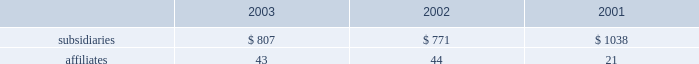Dividends from subsidiaries and affiliates cash dividends received from consolidated subsidiaries and from affiliates accounted for by the equity method were as follows ( in millions ) : .
Guarantees and letters of credit guarantees 2014in connection with certain of its project financing , acquisition , and power purchase agreements , the company has expressly undertaken limited obligations and commitments , most of which will only be effective or will be terminated upon the occurrence of future events .
These obligations and commitments , excluding those collateralized by letter of credit and other obligations discussed below , were limited as of december 31 , 2003 , by the terms of the agreements , to an aggregate of approximately $ 515 million representing 55 agreements with individual exposures ranging from less than $ 1 million up to $ 100 million .
Of this amount , $ 147 million represents credit enhancements for non-recourse debt , and $ 38 million commitments to fund its equity in projects currently under development or in construction .
Letters of credit 2014at december 31 , 2003 , the company had $ 89 million in letters of credit outstanding representing 9 agreements with individual exposures ranging from less than $ 1 million up to $ 36 million , which operate to guarantee performance relating to certain project development and construction activities and subsidiary operations .
The company pays a letter of credit fee ranging from 0.5% ( 0.5 % ) to 5.00% ( 5.00 % ) per annum on the outstanding amounts .
In addition , the company had $ 4 million in surety bonds outstanding at december 31 , 2003. .
What was the average dividend or cash dividends received from consolidated subsidiaries and from affiliates accounted for by the equity method in millions in 2002? 
Computations: (771 / 44)
Answer: 17.52273. 